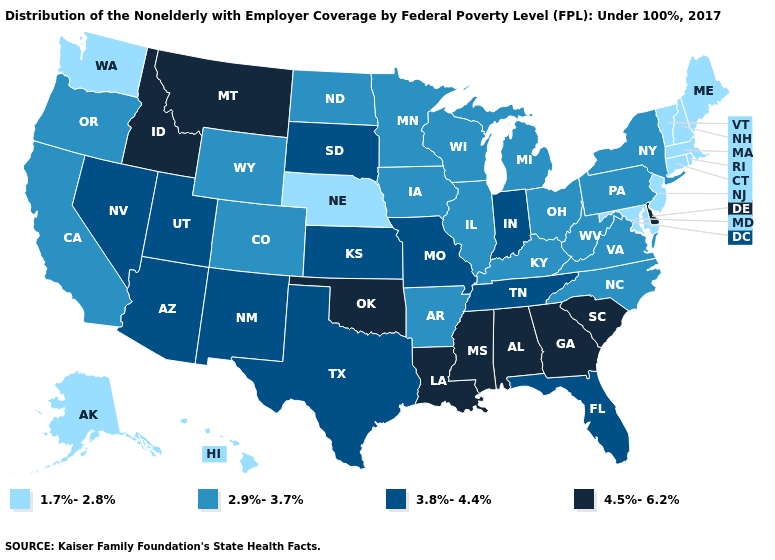Name the states that have a value in the range 3.8%-4.4%?
Keep it brief. Arizona, Florida, Indiana, Kansas, Missouri, Nevada, New Mexico, South Dakota, Tennessee, Texas, Utah. Name the states that have a value in the range 3.8%-4.4%?
Answer briefly. Arizona, Florida, Indiana, Kansas, Missouri, Nevada, New Mexico, South Dakota, Tennessee, Texas, Utah. What is the lowest value in the MidWest?
Quick response, please. 1.7%-2.8%. Name the states that have a value in the range 3.8%-4.4%?
Concise answer only. Arizona, Florida, Indiana, Kansas, Missouri, Nevada, New Mexico, South Dakota, Tennessee, Texas, Utah. What is the value of Missouri?
Concise answer only. 3.8%-4.4%. Does Washington have the lowest value in the USA?
Concise answer only. Yes. What is the lowest value in the West?
Concise answer only. 1.7%-2.8%. Which states have the lowest value in the USA?
Quick response, please. Alaska, Connecticut, Hawaii, Maine, Maryland, Massachusetts, Nebraska, New Hampshire, New Jersey, Rhode Island, Vermont, Washington. Among the states that border Mississippi , which have the lowest value?
Short answer required. Arkansas. What is the value of New Jersey?
Concise answer only. 1.7%-2.8%. Does North Carolina have a lower value than Idaho?
Concise answer only. Yes. Name the states that have a value in the range 4.5%-6.2%?
Quick response, please. Alabama, Delaware, Georgia, Idaho, Louisiana, Mississippi, Montana, Oklahoma, South Carolina. Name the states that have a value in the range 3.8%-4.4%?
Be succinct. Arizona, Florida, Indiana, Kansas, Missouri, Nevada, New Mexico, South Dakota, Tennessee, Texas, Utah. What is the lowest value in the USA?
Quick response, please. 1.7%-2.8%. What is the value of Florida?
Answer briefly. 3.8%-4.4%. 